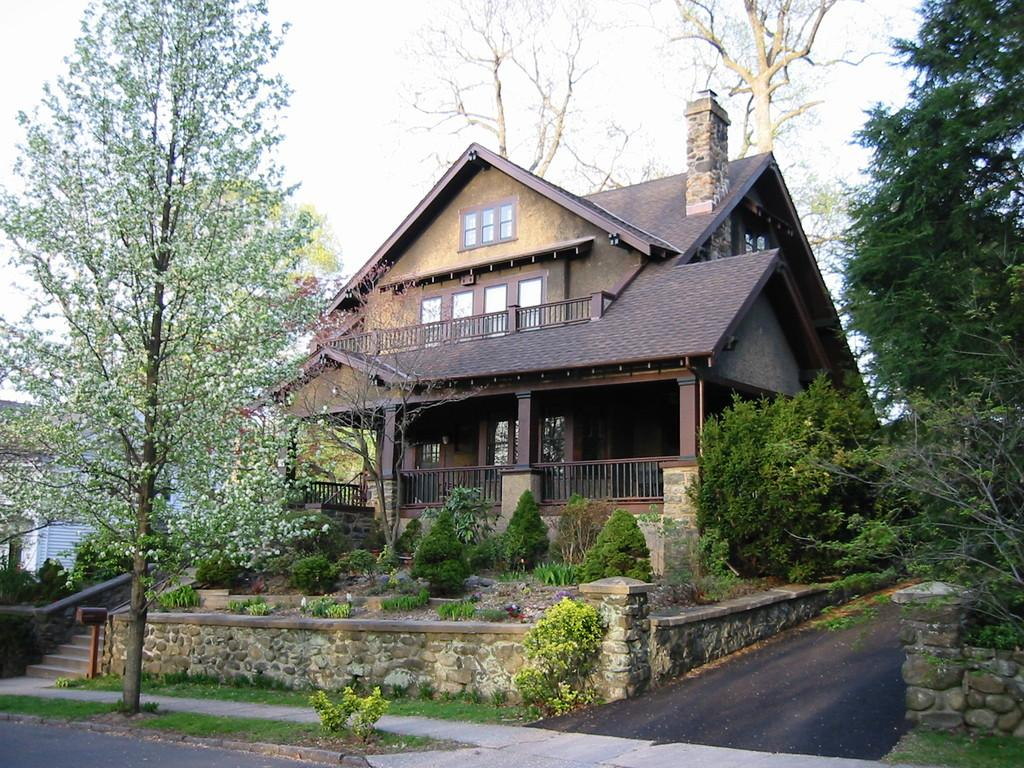What is the main feature of the image? There is a road in the image. What type of vegetation can be seen in the image? There are green trees in the image. What type of structures are present in the image? There are buildings in the image. What can be seen in the background of the image? The sky is visible in the background of the image. What type of wound can be seen on the road in the image? There is no wound present on the road in the image. 